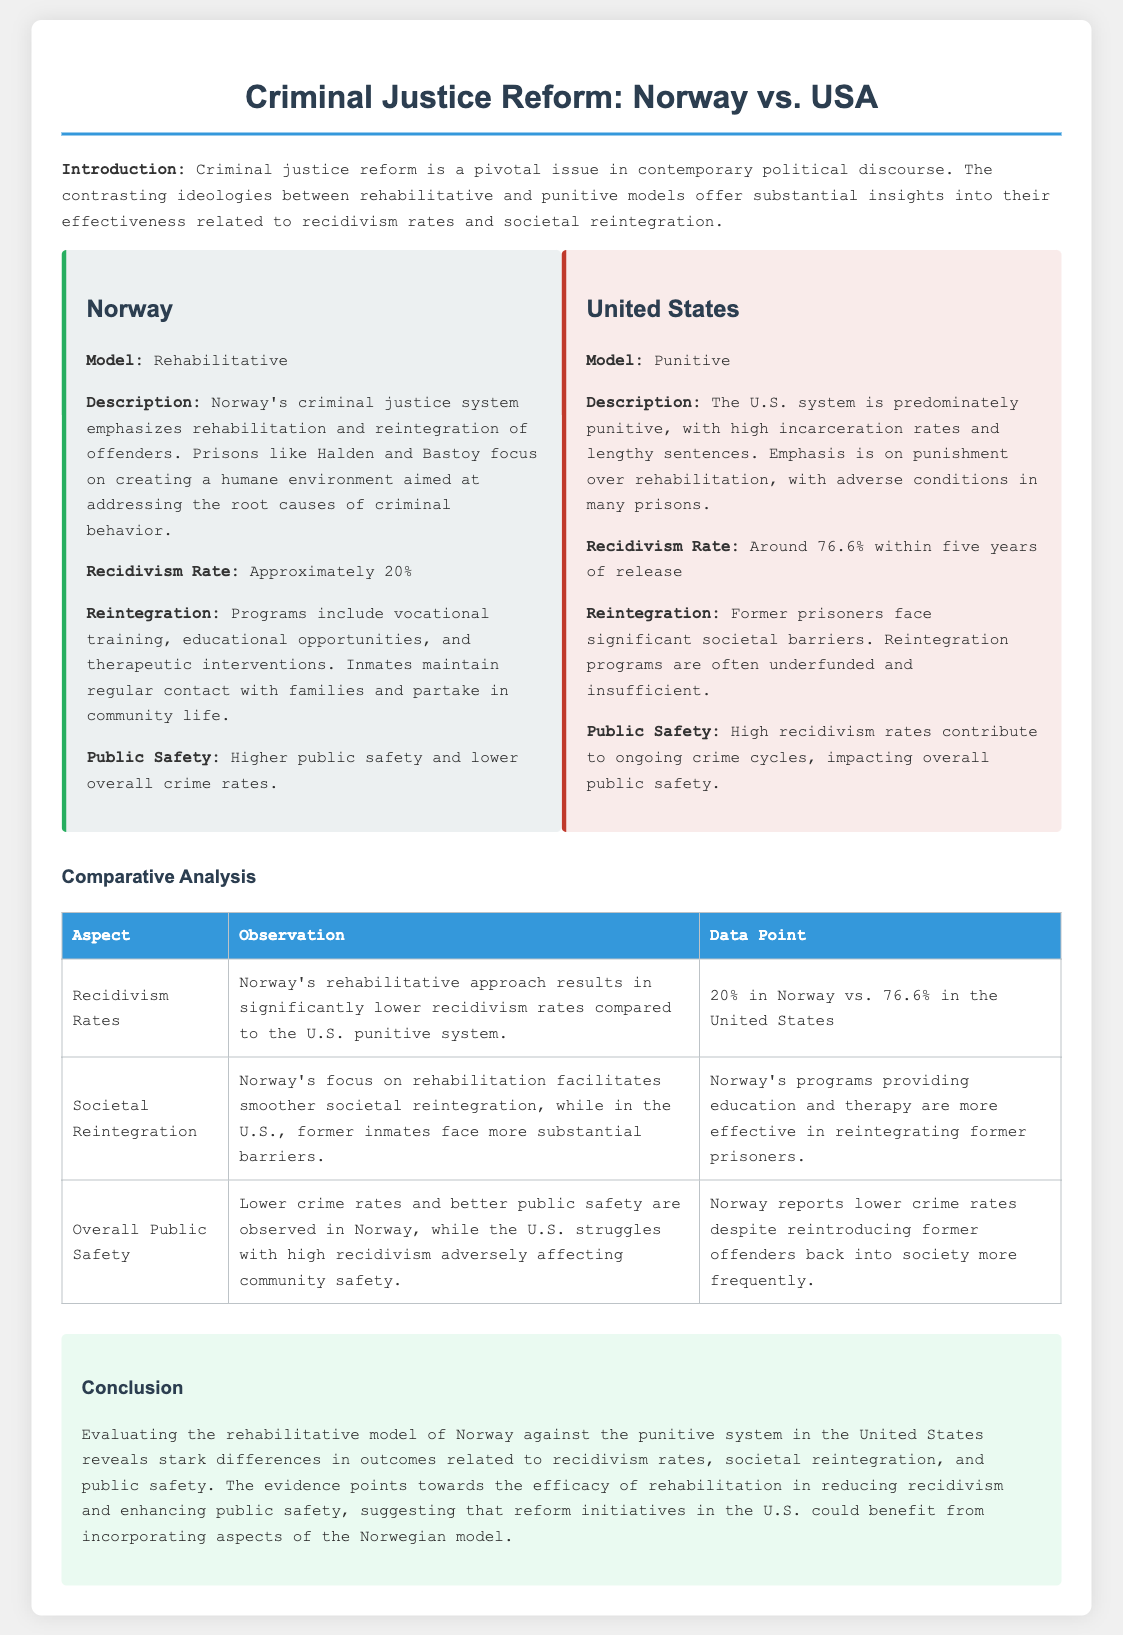What is Norway's recidivism rate? The document states that Norway's recidivism rate is approximately 20%.
Answer: 20% What is the recidivism rate in the United States? The United States has a recidivism rate of around 76.6% within five years of release.
Answer: 76.6% What type of model does Norway use for its criminal justice system? The document describes Norway's model as rehabilitative.
Answer: Rehabilitative What type of model does the United States use for its criminal justice system? The document indicates that the U.S. system is predominately punitive.
Answer: Punitive What key programs does Norway offer for inmate reintegration? The document mentions vocational training, educational opportunities, and therapeutic interventions as key programs.
Answer: Vocational training, educational opportunities, and therapeutic interventions How does societal reintegration in Norway compare to that in the United States? Norway's focus on rehabilitation facilitates smoother societal reintegration, while the U.S. presents more substantial barriers.
Answer: Smoother vs. substantial barriers What is the impact of recidivism rates on overall public safety in the U.S.? The document states that high recidivism rates contribute to ongoing crime cycles, impacting overall public safety.
Answer: Ongoing crime cycles What are the overall crime rates like in Norway despite integrating former offenders? Norway reports lower crime rates despite reintroducing former offenders back into society more frequently.
Answer: Lower crime rates What conclusion does the document draw about the effectiveness of Norway's model? The document concludes that the evidence points towards the efficacy of rehabilitation in reducing recidivism and enhancing public safety.
Answer: Efficacy of rehabilitation 